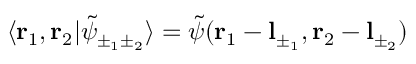Convert formula to latex. <formula><loc_0><loc_0><loc_500><loc_500>\langle r _ { 1 } , r _ { 2 } | \tilde { \psi } _ { \pm _ { 1 } \pm _ { 2 } } \rangle = \tilde { \psi } ( r _ { 1 } - l _ { \pm _ { 1 } } , r _ { 2 } - l _ { \pm _ { 2 } } )</formula> 